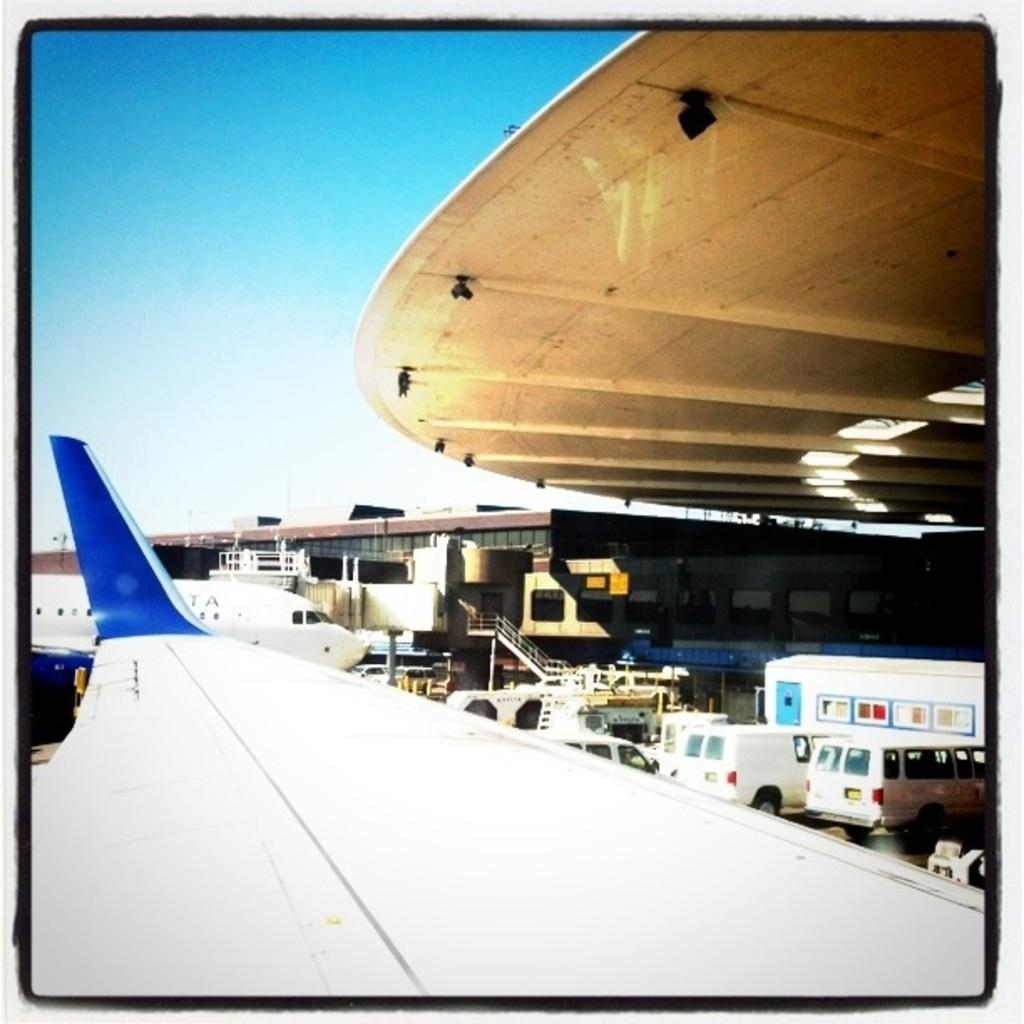What type of location is shown in the image? The image depicts an airport. How many airplanes can be seen in the image? There are two airplanes in the image. What else is present near the airplanes? There are vehicles near the airplanes. What can be seen in the background of the image? There is a large compartment and the sky visible in the background. How much money is being exchanged between the passengers and the airport staff in the image? There is no indication of any money exchange in the image; it only shows airplanes, vehicles, and the airport environment. 